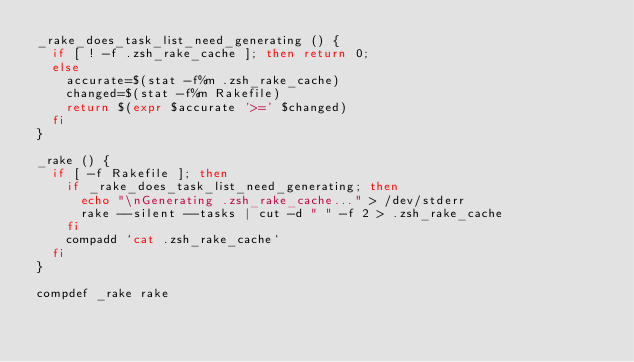Convert code to text. <code><loc_0><loc_0><loc_500><loc_500><_Bash_>_rake_does_task_list_need_generating () {
  if [ ! -f .zsh_rake_cache ]; then return 0;
  else
    accurate=$(stat -f%m .zsh_rake_cache)
    changed=$(stat -f%m Rakefile)
    return $(expr $accurate '>=' $changed)
  fi
}

_rake () {
  if [ -f Rakefile ]; then
    if _rake_does_task_list_need_generating; then
      echo "\nGenerating .zsh_rake_cache..." > /dev/stderr
      rake --silent --tasks | cut -d " " -f 2 > .zsh_rake_cache
    fi
    compadd `cat .zsh_rake_cache`
  fi
}

compdef _rake rake
</code> 